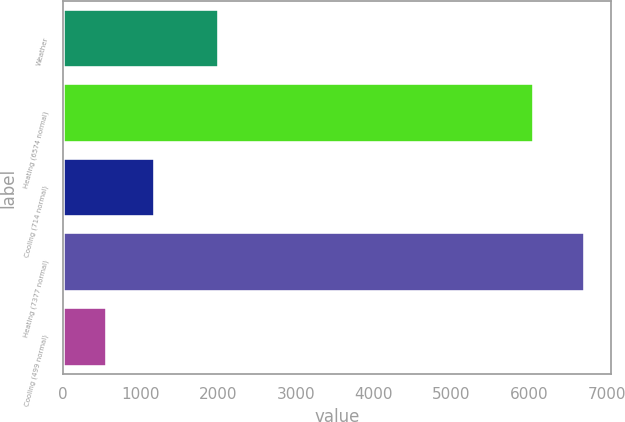<chart> <loc_0><loc_0><loc_500><loc_500><bar_chart><fcel>Weather<fcel>Heating (6574 normal)<fcel>Cooling (714 normal)<fcel>Heating (7377 normal)<fcel>Cooling (499 normal)<nl><fcel>2016<fcel>6068<fcel>1186.3<fcel>6715<fcel>572<nl></chart> 